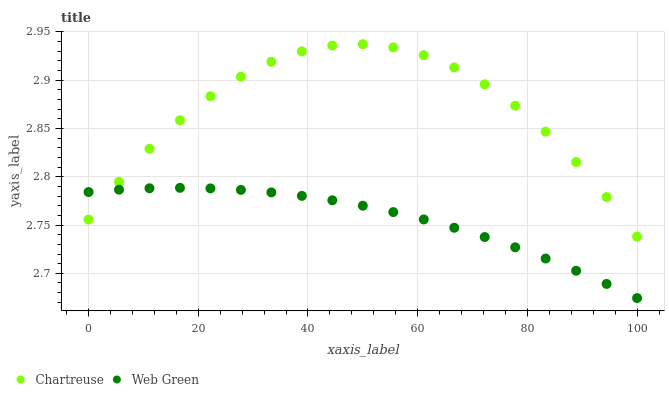Does Web Green have the minimum area under the curve?
Answer yes or no. Yes. Does Chartreuse have the maximum area under the curve?
Answer yes or no. Yes. Does Web Green have the maximum area under the curve?
Answer yes or no. No. Is Web Green the smoothest?
Answer yes or no. Yes. Is Chartreuse the roughest?
Answer yes or no. Yes. Is Web Green the roughest?
Answer yes or no. No. Does Web Green have the lowest value?
Answer yes or no. Yes. Does Chartreuse have the highest value?
Answer yes or no. Yes. Does Web Green have the highest value?
Answer yes or no. No. Does Chartreuse intersect Web Green?
Answer yes or no. Yes. Is Chartreuse less than Web Green?
Answer yes or no. No. Is Chartreuse greater than Web Green?
Answer yes or no. No. 